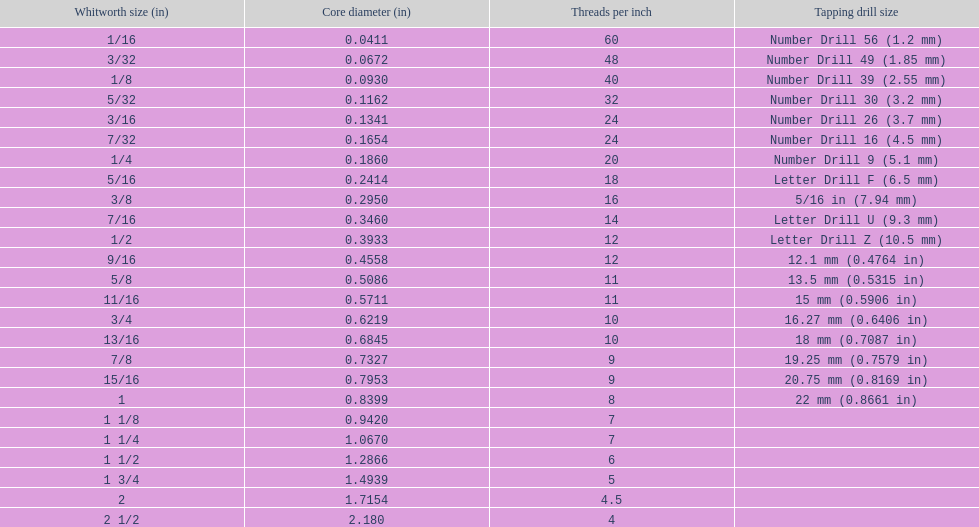What is the next whitworth size (in) below 1/8? 5/32. 